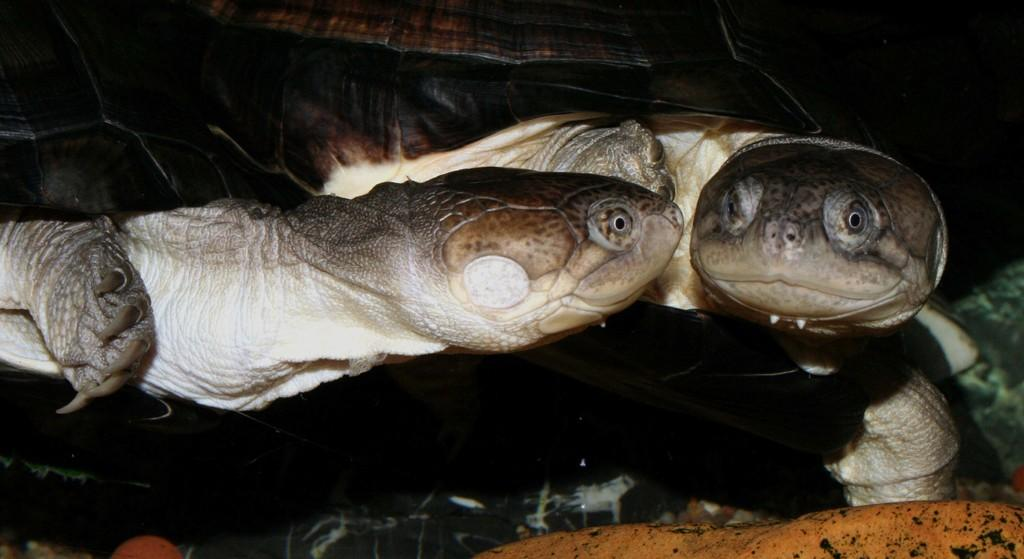What animals are present in the image? There are two tortoises in the image. Where are the tortoises located in the image? The tortoises are at the bottom of the image. What type of sugar can be seen on the tortoises in the image? There is no sugar present on the tortoises in the image. How many zebras are visible in the image? There are no zebras present in the image; it features two tortoises. 